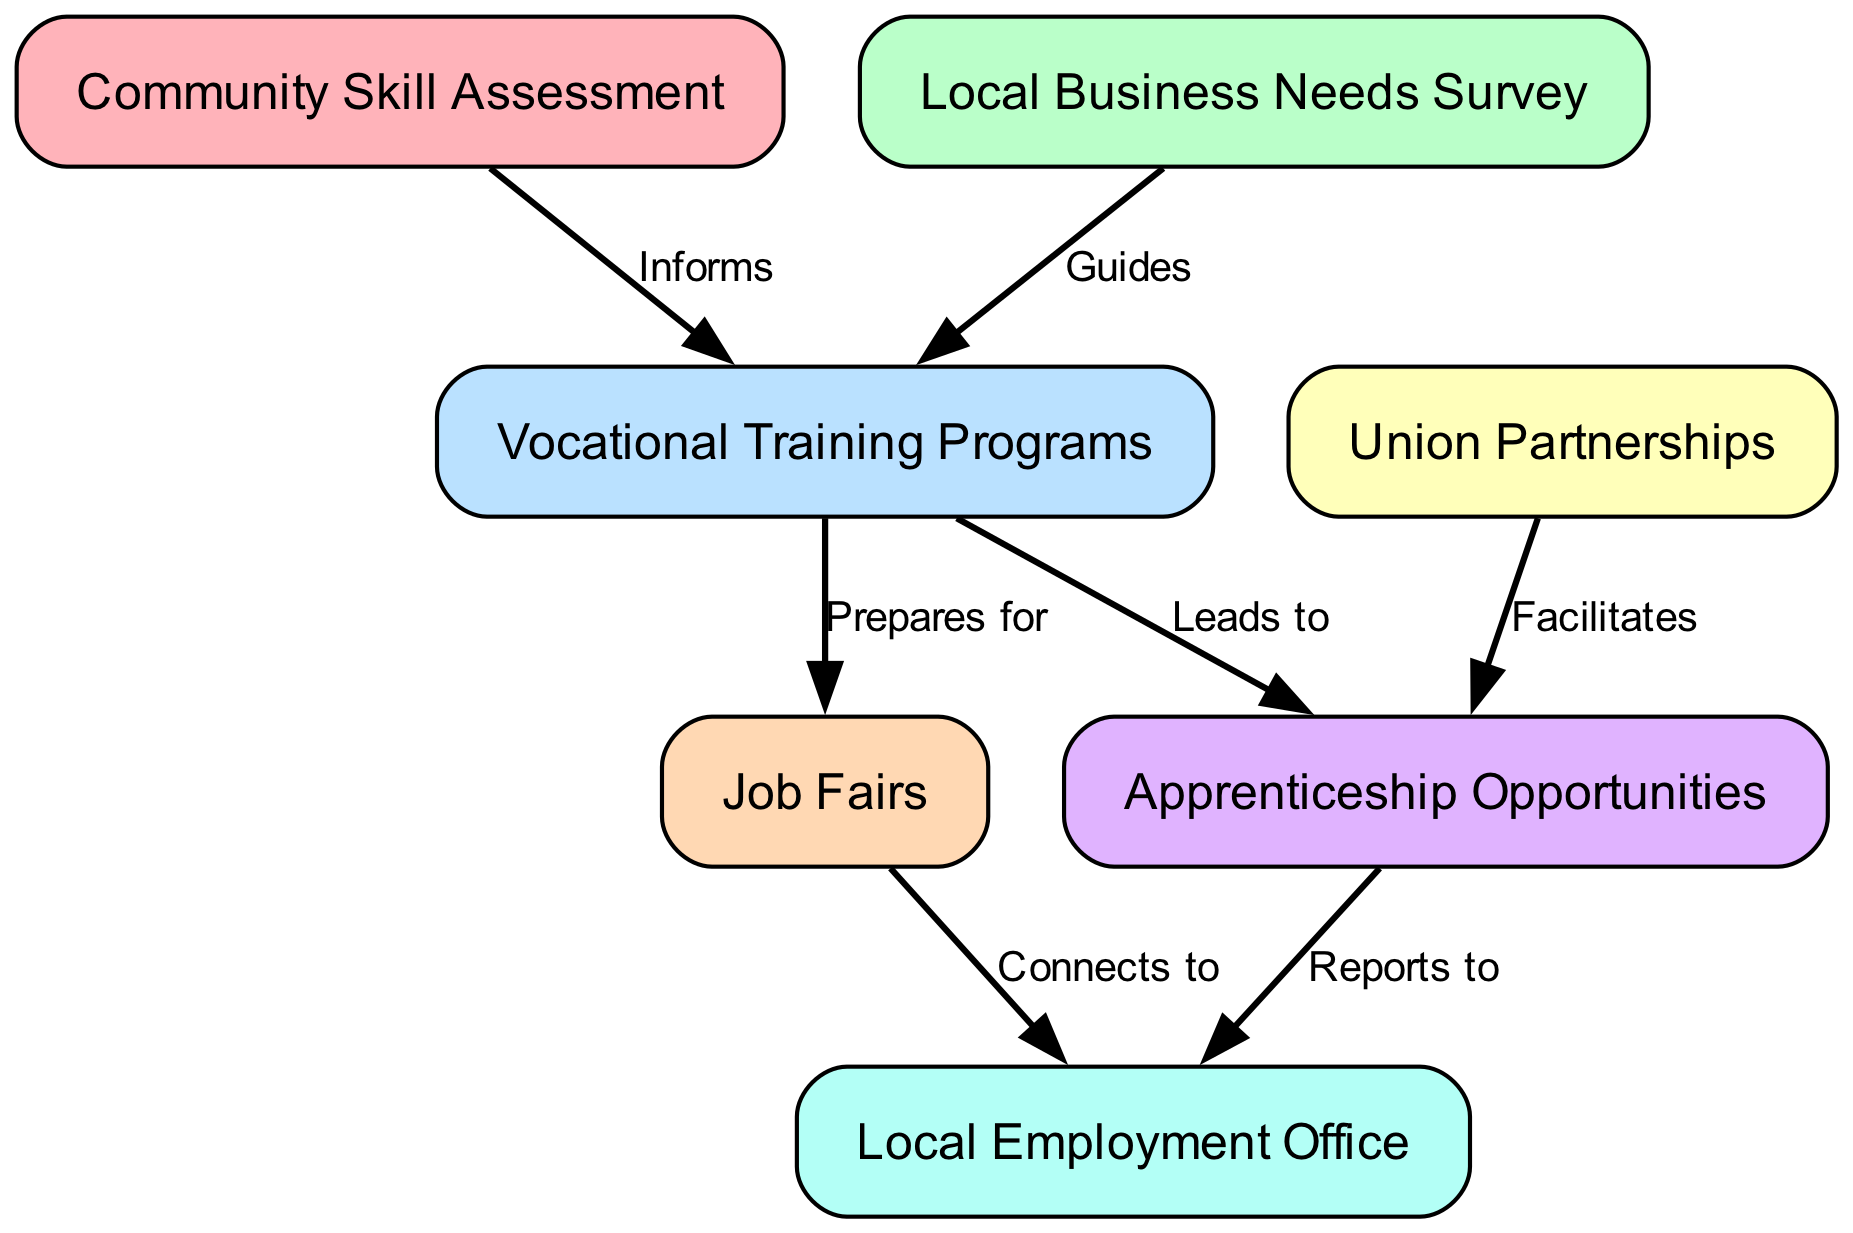What is the first step in the initiative? The diagram shows that the first step in the initiative is "Community Skill Assessment," which is the first node.
Answer: Community Skill Assessment How many nodes are there in total? By counting the nodes provided in the diagram, we see there are seven distinct nodes representing different steps in the initiative.
Answer: 7 What does "Local Business Needs Survey" guide? The diagram indicates that the "Local Business Needs Survey" directs or guides the "Vocational Training Programs," implying its role in shaping training based on business needs.
Answer: Vocational Training Programs Which two nodes are linked by the label "Connects to"? The edge labeled "Connects to" shows a direct relationship between "Job Fairs" and "Local Employment Office." This indicates that job fairs provide a connection to employment opportunities through the local office.
Answer: Local Employment Office What does "Union Partnerships" facilitate? The relationship in the diagram shows that "Union Partnerships" facilitates "Apprenticeship Opportunities," indicating that unions play a role in creating apprenticeship chances for individuals.
Answer: Apprenticeship Opportunities Which node does "Vocational Training Programs" prepare candidates for? According to the diagram, "Vocational Training Programs" are designed to prepare candidates for "Job Fairs," signifying that the skills learned will aid in job seeking.
Answer: Job Fairs What is the last node that reports to the Local Employment Office? The diagram clearly illustrates that "Apprenticeship Opportunities" reports to the "Local Employment Office" as the final step before reaching employment-related services.
Answer: Local Employment Office Which step leads to participation in apprenticeship opportunities? The diagram specifies that "Vocational Training Programs" lead to "Apprenticeship Opportunities," indicating that these programs are a pathway to gaining apprenticeships.
Answer: Apprenticeship Opportunities What is the relationship between "Local Business Needs Survey" and "Vocational Training Programs"? The diagram demonstrates that "Local Business Needs Survey" guides "Vocational Training Programs," which means that business needs drive the training offered.
Answer: Guides 